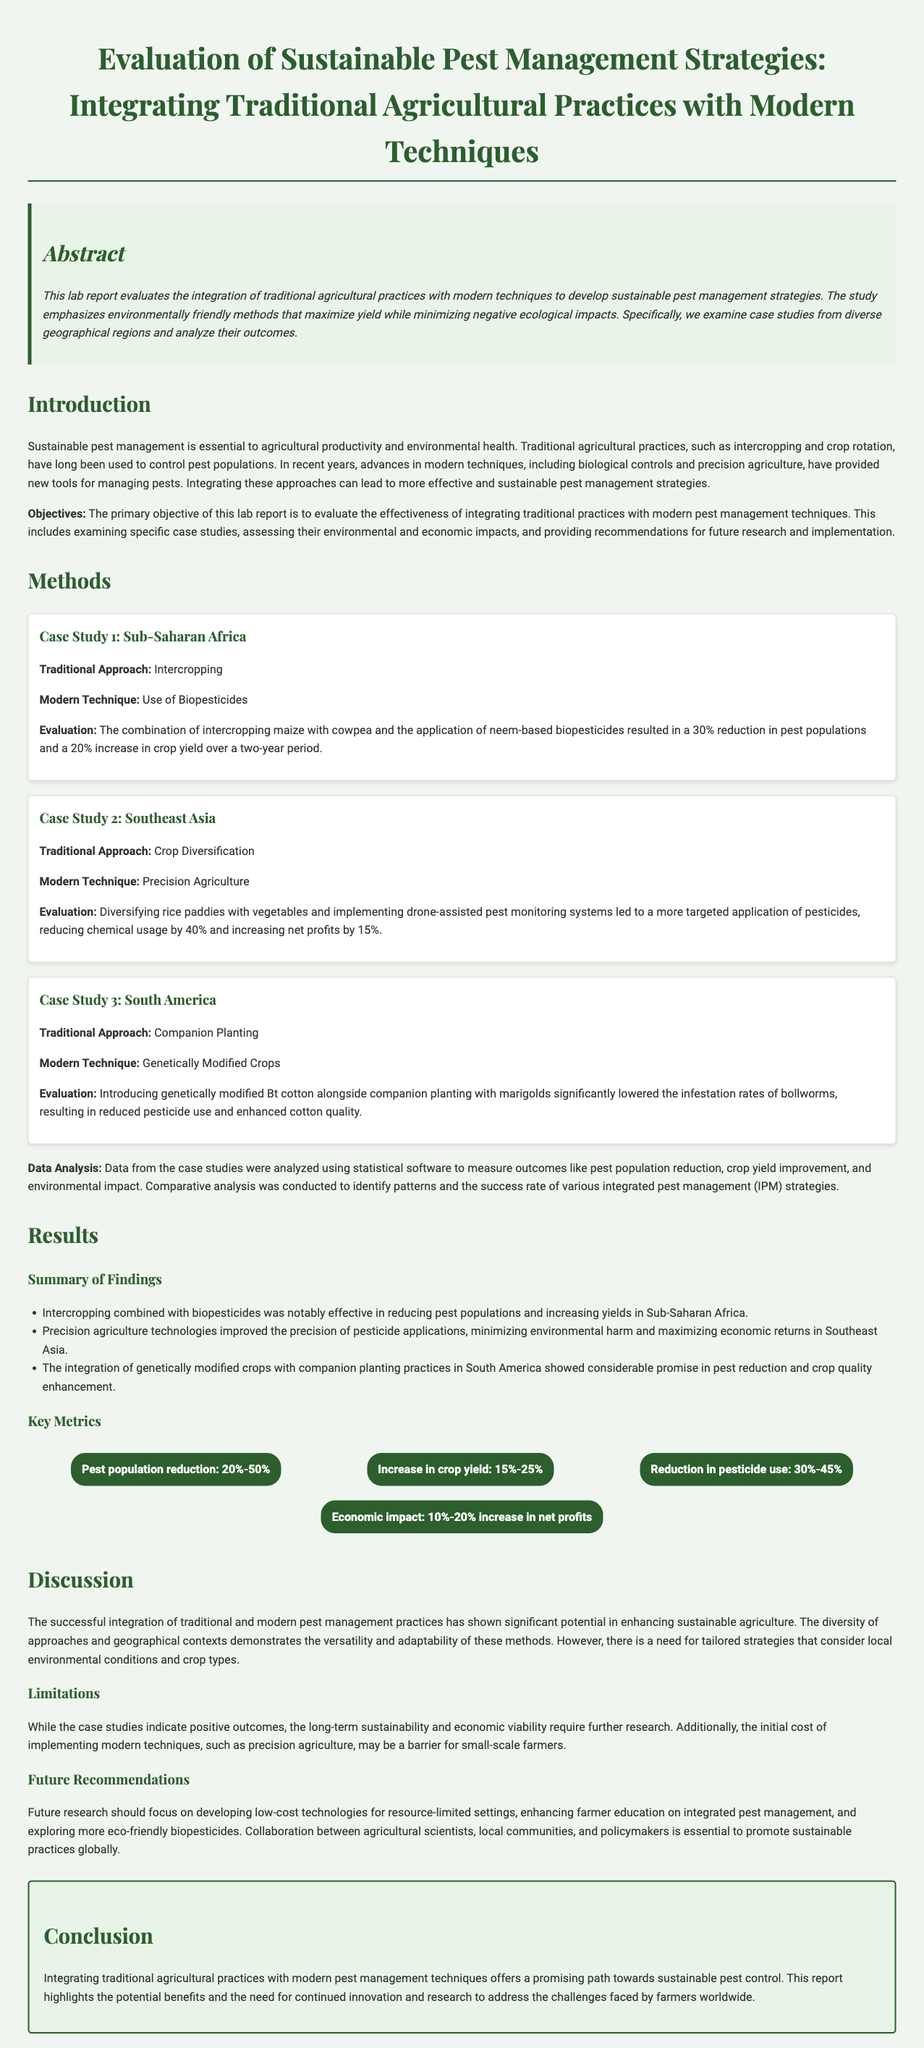What is the primary objective of the lab report? The primary objective is to evaluate the effectiveness of integrating traditional practices with modern pest management techniques.
Answer: Evaluate the effectiveness of integrating traditional practices with modern pest management techniques What percentage reduction in pest populations was achieved in Sub-Saharan Africa? The evaluation in Sub-Saharan Africa indicated a 30% reduction in pest populations.
Answer: 30% Which traditional approach was utilized in Southeast Asia? The traditional approach used in Southeast Asia was crop diversification.
Answer: Crop Diversification What was the increase in net profits reported in Southeast Asia? The implementation in Southeast Asia resulted in a 15% increase in net profits.
Answer: 15% What kind of crops were introduced alongside companion planting in South America? Genetically modified Bt cotton was introduced alongside companion planting.
Answer: Genetically Modified Bt cotton What was a major limitation mentioned in the report? The initial cost of implementing modern techniques may be a barrier for small-scale farmers.
Answer: Initial cost of implementing modern techniques What are the key metrics for crop yield increase mentioned? The increase in crop yield is noted to be between 15% and 25%.
Answer: 15%-25% What future recommendation involves collaboration? Collaboration between agricultural scientists, local communities, and policymakers is essential.
Answer: Collaboration between agricultural scientists, local communities, and policymakers What type of strategies does the report suggest need to be tailored? The report suggests that strategies should be tailored to consider local environmental conditions and crop types.
Answer: Local environmental conditions and crop types 